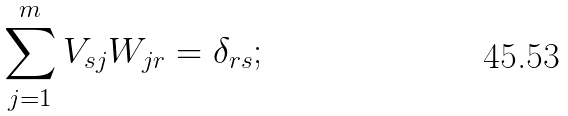Convert formula to latex. <formula><loc_0><loc_0><loc_500><loc_500>\sum _ { j = 1 } ^ { m } V _ { s j } W _ { j r } = \delta _ { r s } ;</formula> 